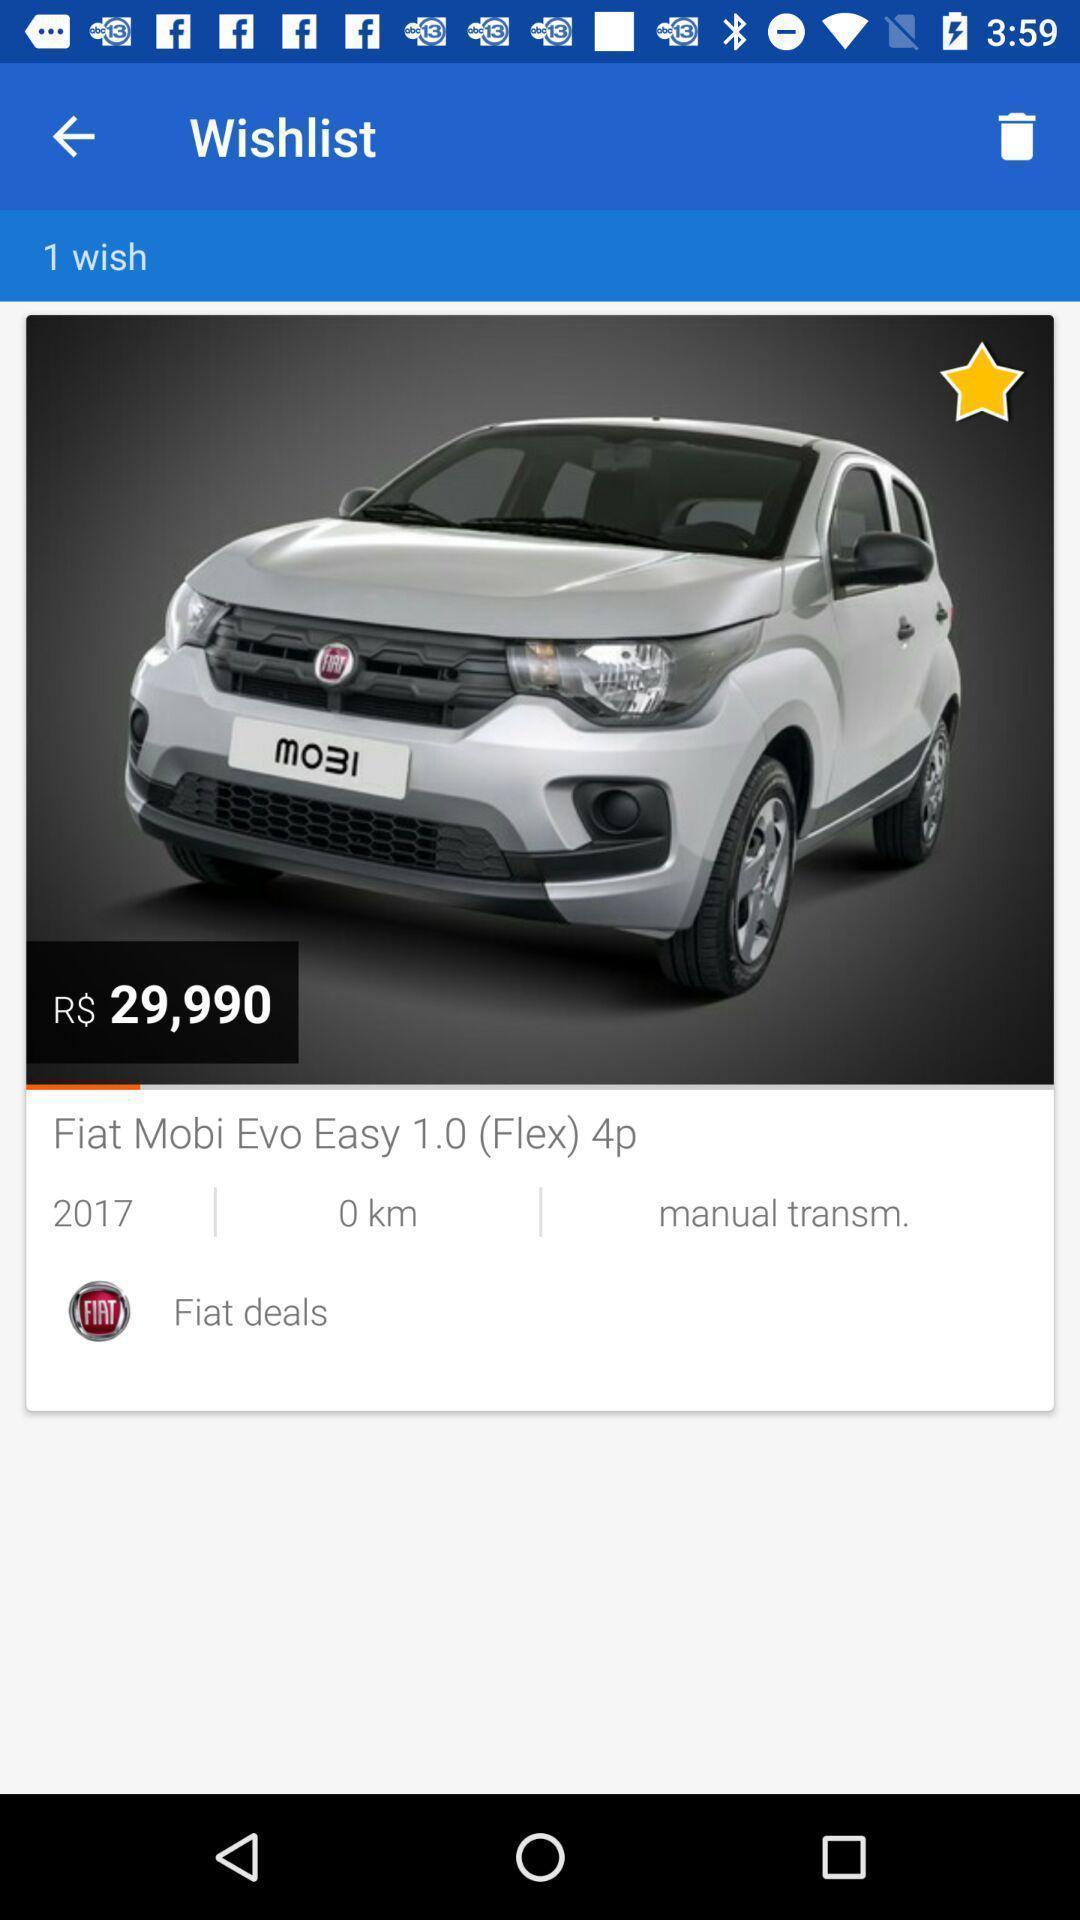Describe the key features of this screenshot. Screen displaying car under wishlist page. 